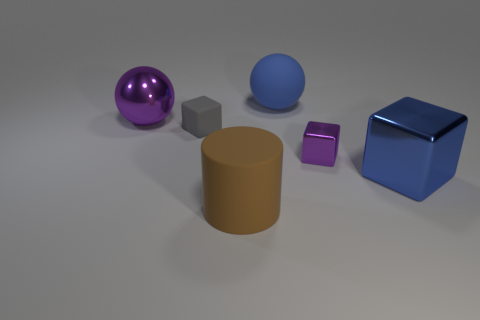Add 3 big shiny balls. How many objects exist? 9 Subtract all cylinders. How many objects are left? 5 Add 3 big metallic balls. How many big metallic balls exist? 4 Subtract 0 red blocks. How many objects are left? 6 Subtract all blue rubber balls. Subtract all blue metallic cubes. How many objects are left? 4 Add 4 large blue cubes. How many large blue cubes are left? 5 